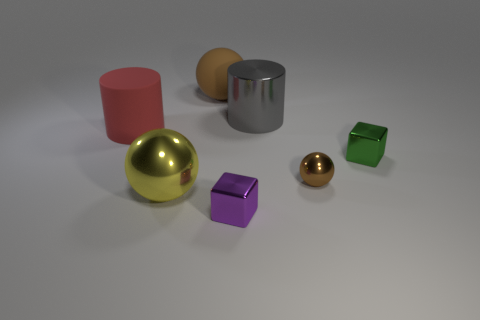The big metallic thing that is behind the small block behind the big yellow ball is what color?
Offer a terse response. Gray. Does the big red cylinder have the same material as the cube that is left of the big gray metallic object?
Your response must be concise. No. There is a ball that is on the right side of the big cylinder right of the large metallic thing that is in front of the green cube; what color is it?
Offer a terse response. Brown. Is there any other thing that is the same shape as the large gray object?
Give a very brief answer. Yes. Is the number of small purple things greater than the number of small gray blocks?
Provide a short and direct response. Yes. What number of balls are both in front of the large red cylinder and left of the tiny purple cube?
Offer a terse response. 1. How many large cylinders are on the left side of the big cylinder that is to the right of the yellow sphere?
Keep it short and to the point. 1. Does the shiny cube that is in front of the tiny brown ball have the same size as the red matte object behind the small purple metal cube?
Ensure brevity in your answer.  No. How many red blocks are there?
Your answer should be very brief. 0. What number of blocks are the same material as the large yellow thing?
Offer a terse response. 2. 